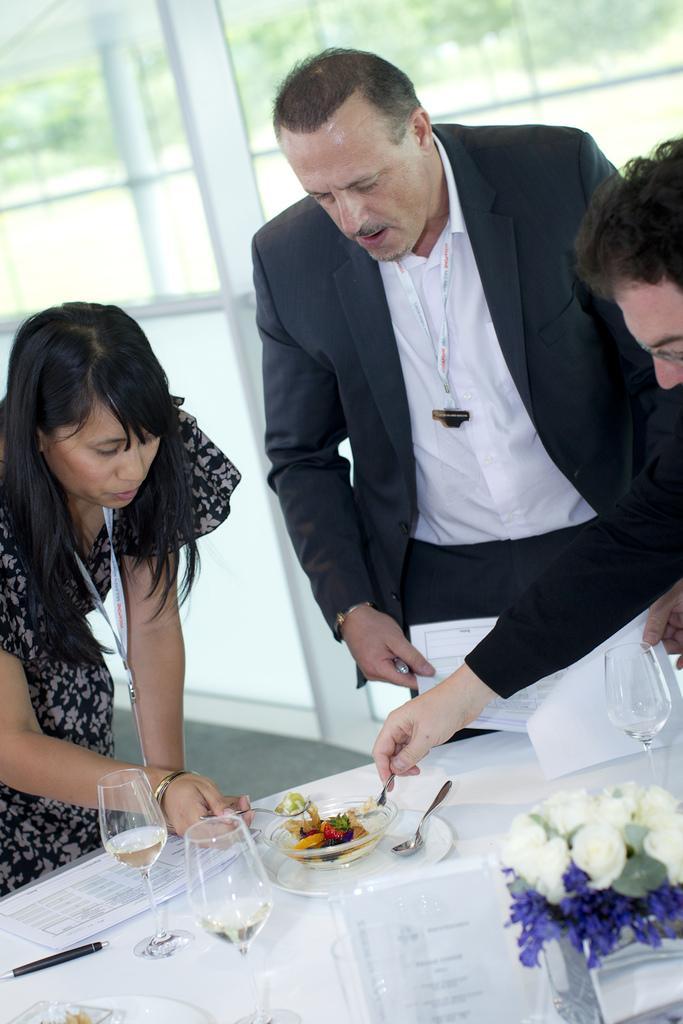In one or two sentences, can you explain what this image depicts? In this image there is a white table on which there are glasses,papers,pens and a flower vase. There are two persons who are taking the food with the spoons. The food is on the table. In the middle there is a person who is holding the papers. In the background there are glass windows. On the left side there is a woman who is having an id card. 